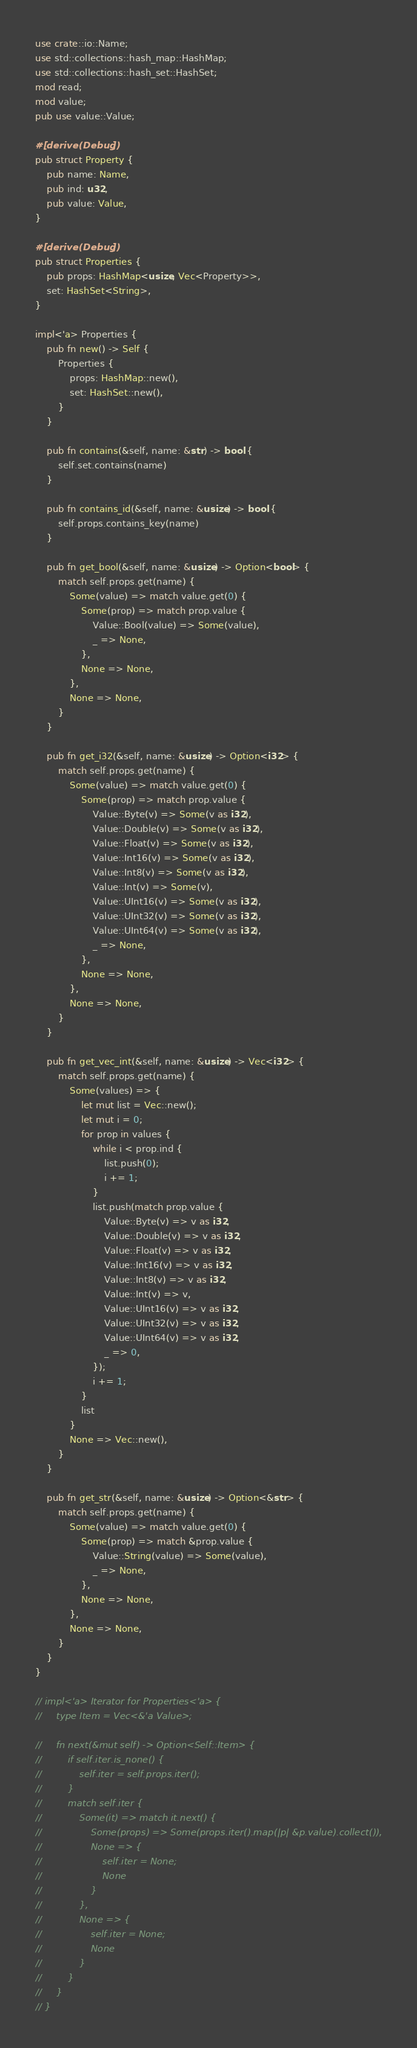<code> <loc_0><loc_0><loc_500><loc_500><_Rust_>use crate::io::Name;
use std::collections::hash_map::HashMap;
use std::collections::hash_set::HashSet;
mod read;
mod value;
pub use value::Value;

#[derive(Debug)]
pub struct Property {
    pub name: Name,
    pub ind: u32,
    pub value: Value,
}

#[derive(Debug)]
pub struct Properties {
    pub props: HashMap<usize, Vec<Property>>,
    set: HashSet<String>,
}

impl<'a> Properties {
    pub fn new() -> Self {
        Properties {
            props: HashMap::new(),
            set: HashSet::new(),
        }
    }

    pub fn contains(&self, name: &str) -> bool {
        self.set.contains(name)
    }

    pub fn contains_id(&self, name: &usize) -> bool {
        self.props.contains_key(name)
    }

    pub fn get_bool(&self, name: &usize) -> Option<bool> {
        match self.props.get(name) {
            Some(value) => match value.get(0) {
                Some(prop) => match prop.value {
                    Value::Bool(value) => Some(value),
                    _ => None,
                },
                None => None,
            },
            None => None,
        }
    }

    pub fn get_i32(&self, name: &usize) -> Option<i32> {
        match self.props.get(name) {
            Some(value) => match value.get(0) {
                Some(prop) => match prop.value {
                    Value::Byte(v) => Some(v as i32),
                    Value::Double(v) => Some(v as i32),
                    Value::Float(v) => Some(v as i32),
                    Value::Int16(v) => Some(v as i32),
                    Value::Int8(v) => Some(v as i32),
                    Value::Int(v) => Some(v),
                    Value::UInt16(v) => Some(v as i32),
                    Value::UInt32(v) => Some(v as i32),
                    Value::UInt64(v) => Some(v as i32),
                    _ => None,
                },
                None => None,
            },
            None => None,
        }
    }

    pub fn get_vec_int(&self, name: &usize) -> Vec<i32> {
        match self.props.get(name) {
            Some(values) => {
                let mut list = Vec::new();
                let mut i = 0;
                for prop in values {
                    while i < prop.ind {
                        list.push(0);
                        i += 1;
                    }
                    list.push(match prop.value {
                        Value::Byte(v) => v as i32,
                        Value::Double(v) => v as i32,
                        Value::Float(v) => v as i32,
                        Value::Int16(v) => v as i32,
                        Value::Int8(v) => v as i32,
                        Value::Int(v) => v,
                        Value::UInt16(v) => v as i32,
                        Value::UInt32(v) => v as i32,
                        Value::UInt64(v) => v as i32,
                        _ => 0,
                    });
                    i += 1;
                }
                list
            }
            None => Vec::new(),
        }
    }

    pub fn get_str(&self, name: &usize) -> Option<&str> {
        match self.props.get(name) {
            Some(value) => match value.get(0) {
                Some(prop) => match &prop.value {
                    Value::String(value) => Some(value),
                    _ => None,
                },
                None => None,
            },
            None => None,
        }
    }
}

// impl<'a> Iterator for Properties<'a> {
//     type Item = Vec<&'a Value>;

//     fn next(&mut self) -> Option<Self::Item> {
//         if self.iter.is_none() {
//             self.iter = self.props.iter();
//         }
//         match self.iter {
//             Some(it) => match it.next() {
//                 Some(props) => Some(props.iter().map(|p| &p.value).collect()),
//                 None => {
//                     self.iter = None;
//                     None
//                 }
//             },
//             None => {
//                 self.iter = None;
//                 None
//             }
//         }
//     }
// }
</code> 